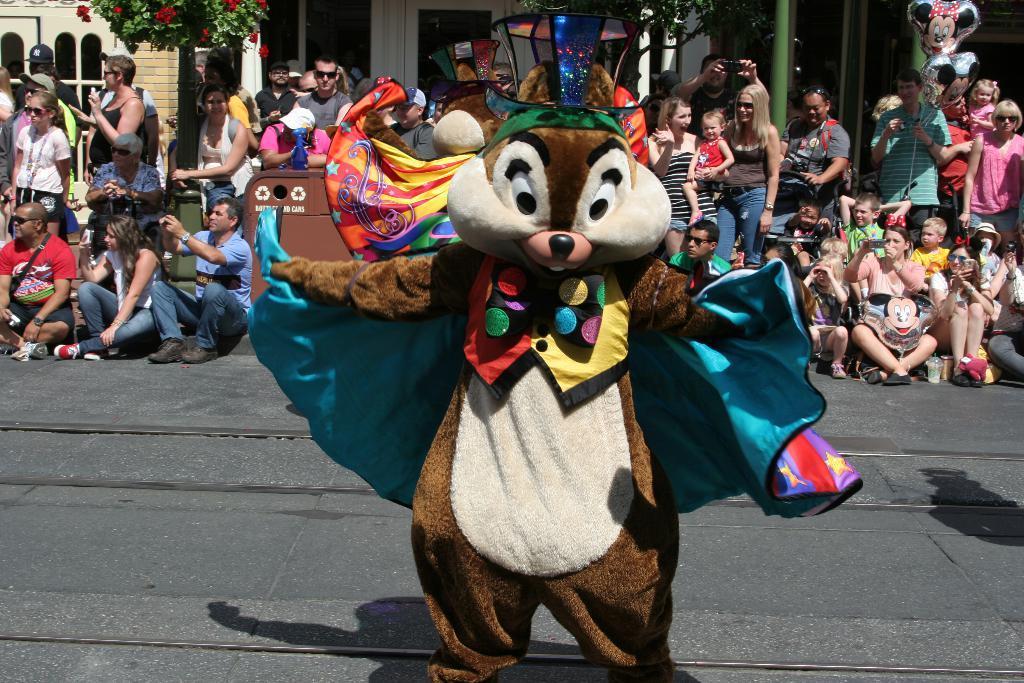Could you give a brief overview of what you see in this image? In this picture, there is a person wearing a squirrel costume and he is standing on the road. Behind the, there are people sitting on the footpath and clicking pictures. Behind them, there are people standing and staring the play. In the background, there are buildings, trees, poles etc. 